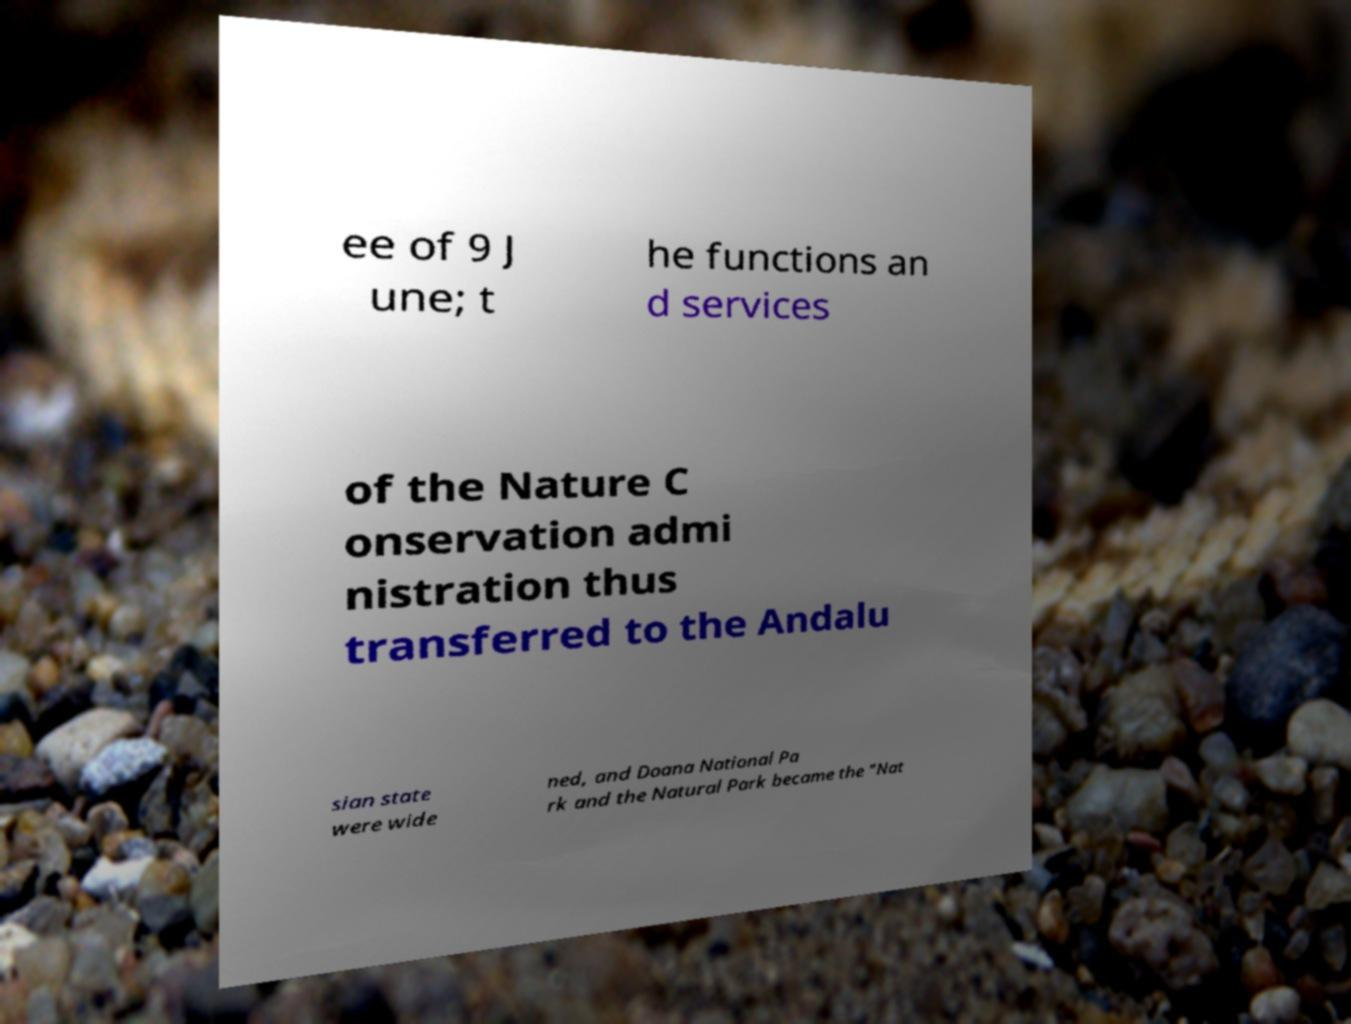Could you assist in decoding the text presented in this image and type it out clearly? ee of 9 J une; t he functions an d services of the Nature C onservation admi nistration thus transferred to the Andalu sian state were wide ned, and Doana National Pa rk and the Natural Park became the "Nat 